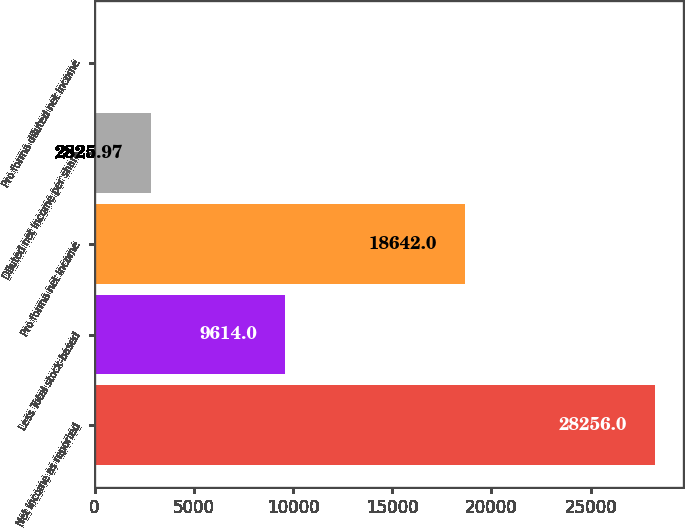Convert chart. <chart><loc_0><loc_0><loc_500><loc_500><bar_chart><fcel>Net income as reported<fcel>Less Total stock-based<fcel>Pro forma net income<fcel>Diluted net income per share<fcel>Pro forma diluted net income<nl><fcel>28256<fcel>9614<fcel>18642<fcel>2825.97<fcel>0.41<nl></chart> 